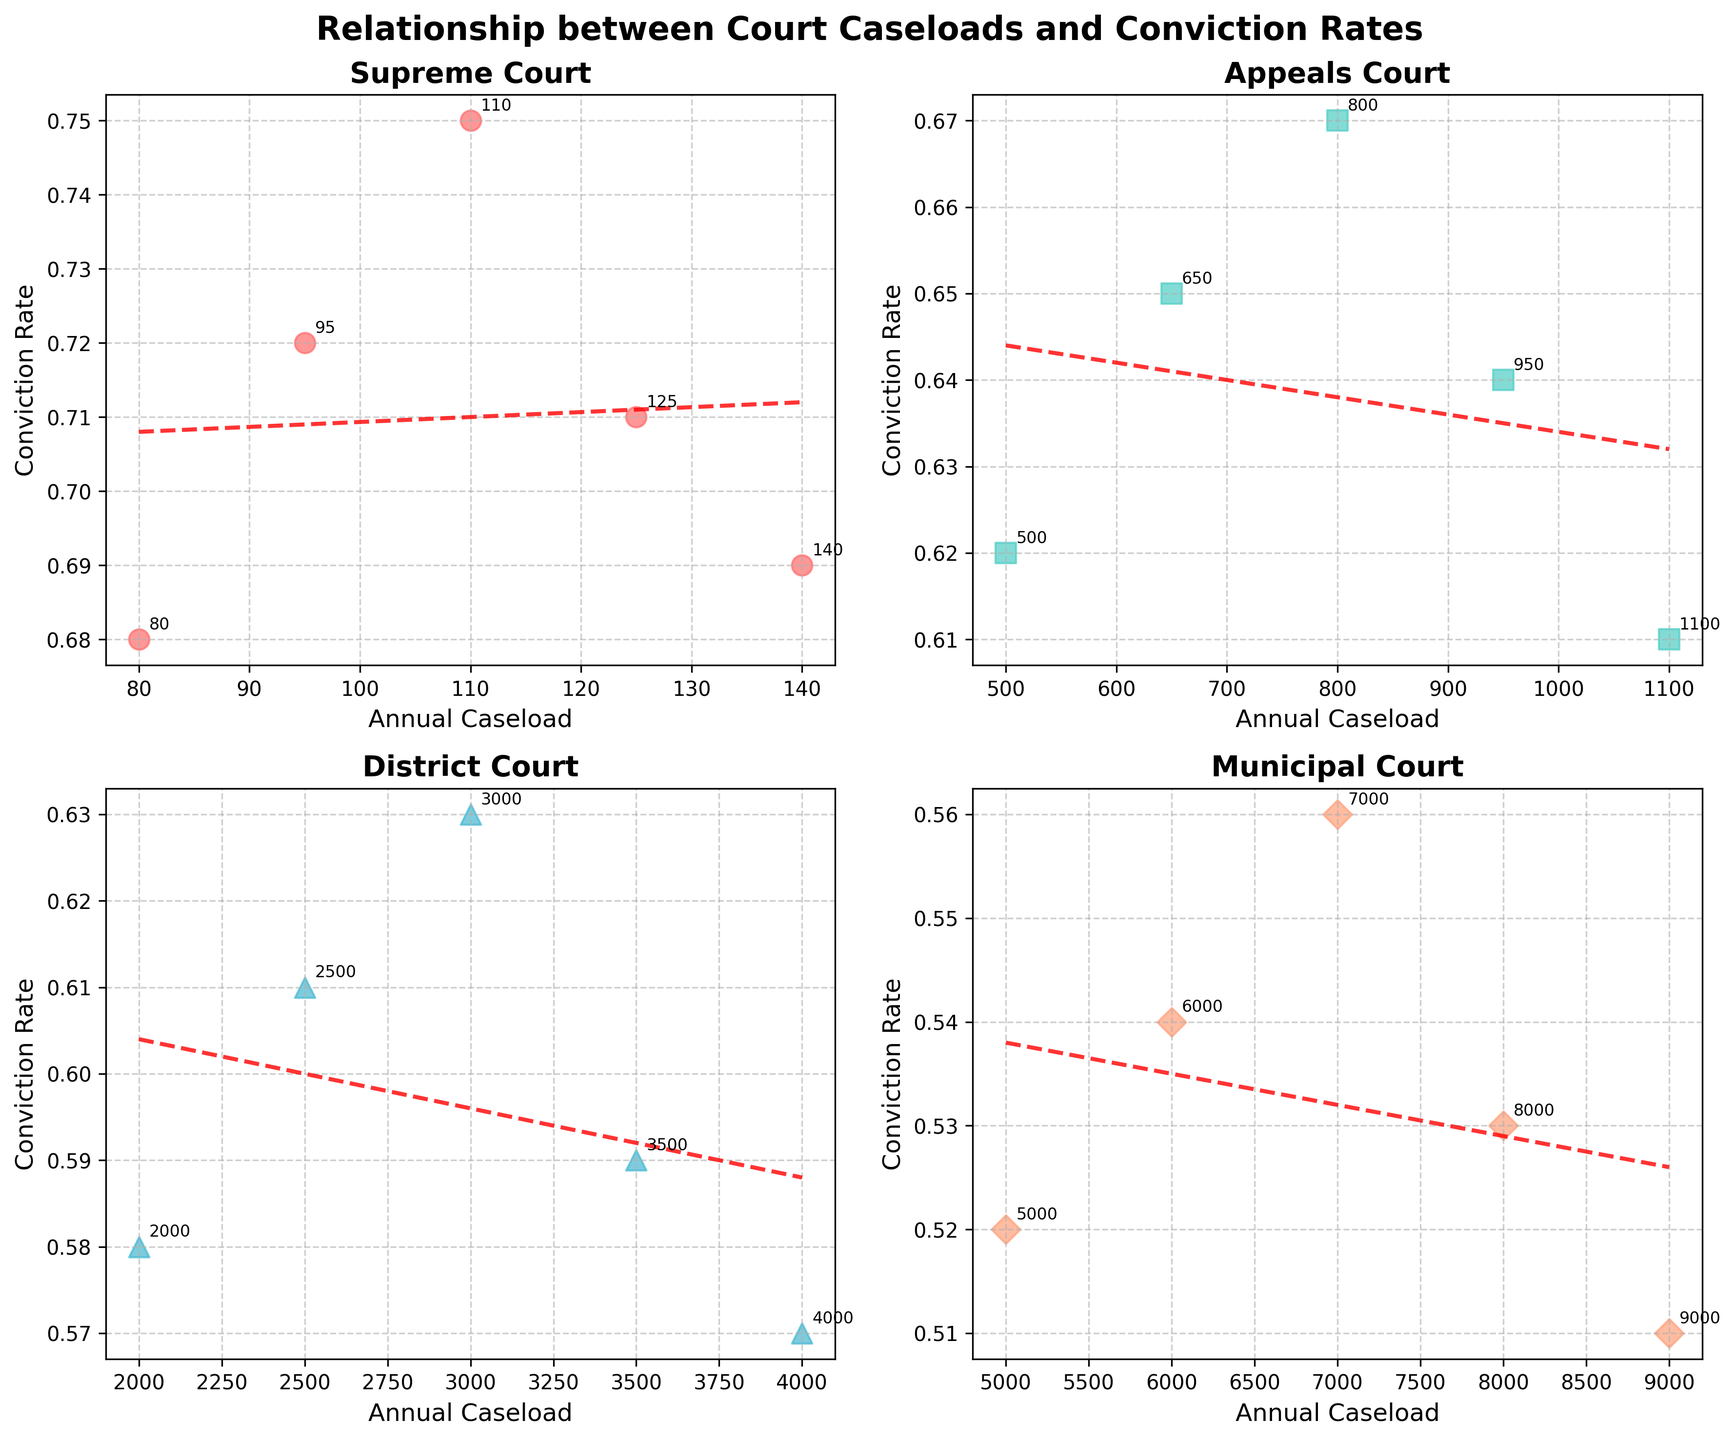What is the title of the figure? The title of the figure is located at the top center of the plot, clearly stating the subject of the visualization. The title helps the viewer to understand the context of the data being presented.
Answer: Relationship between Court Caseloads and Conviction Rates Which court level has the highest annual caseload? The different court levels are marked on individual subplots. By observing the x-axes, the Municipal Court has the highest values, peaking at 9000.
Answer: Municipal Court What is the trend in conviction rates as caseload increases for the Supreme Court? The scatter plot for the Supreme Court shows the relationship between annual caseloads and conviction rates. The trend line for the Supreme Court subplot is decreasing slightly, indicating that as the caseload increases, the conviction rate slightly decreases.
Answer: Decreasing slightly Which court level has the most consistent trend in conviction rates? By examining the scatter plots, we can observe the spread and the trend lines. The Supreme Court subplot has the least scattered points around the trend line, indicating the most consistent trend.
Answer: Supreme Court What is the approximate correlation between annual caseload and conviction rate for the Appeals Court? Observing the subplot for the Appeals Court, the trend line appears almost flat. This shows a weak positive slope but indicates that there is little to no significant correlation between annual caseload and conviction rate.
Answer: Weak positive correlation Which court level has the lowest conviction rate at its highest caseload? Among the subplots, the highest caseload for the District Court is 4000, and the conviction rate for that data point is around 0.57, which is lower compared to the other highest caseload points in the subplot.
Answer: District Court Compare the range of annual caseloads across all court levels. By looking at the x-axis ranges in each subplot, we see:
- Supreme Court: ~80 to 140
- Appeals Court: ~500 to 1100
- District Court: ~2000 to 4000
- Municipal Court: ~5000 to 9000
The range increases as we move from the Supreme Court to the Municipal Court.
Answer: The range increases from Supreme Court to Municipal Court 